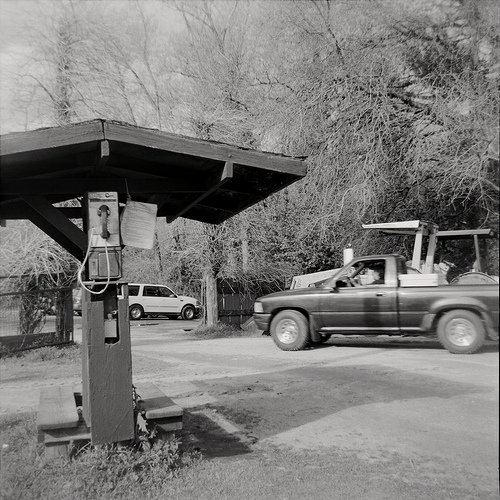Please provide a short description for this region: [0.24, 0.4, 0.32, 0.5]. The bounding box [0.24, 0.4, 0.32, 0.5] features a piece of paper hanging next to the pay phone, possibly a notice or instruction sheet. 